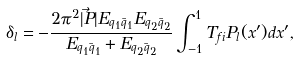<formula> <loc_0><loc_0><loc_500><loc_500>\delta _ { l } = - \frac { 2 \pi ^ { 2 } | \vec { P } | E _ { q _ { 1 } \bar { q } _ { 1 } } E _ { q _ { 2 } \bar { q } _ { 2 } } } { E _ { q _ { 1 } \bar { q } _ { 1 } } + E _ { q _ { 2 } \bar { q } _ { 2 } } } \int _ { - 1 } ^ { 1 } T _ { f i } P _ { l } ( x ^ { \prime } ) d x ^ { \prime } ,</formula> 